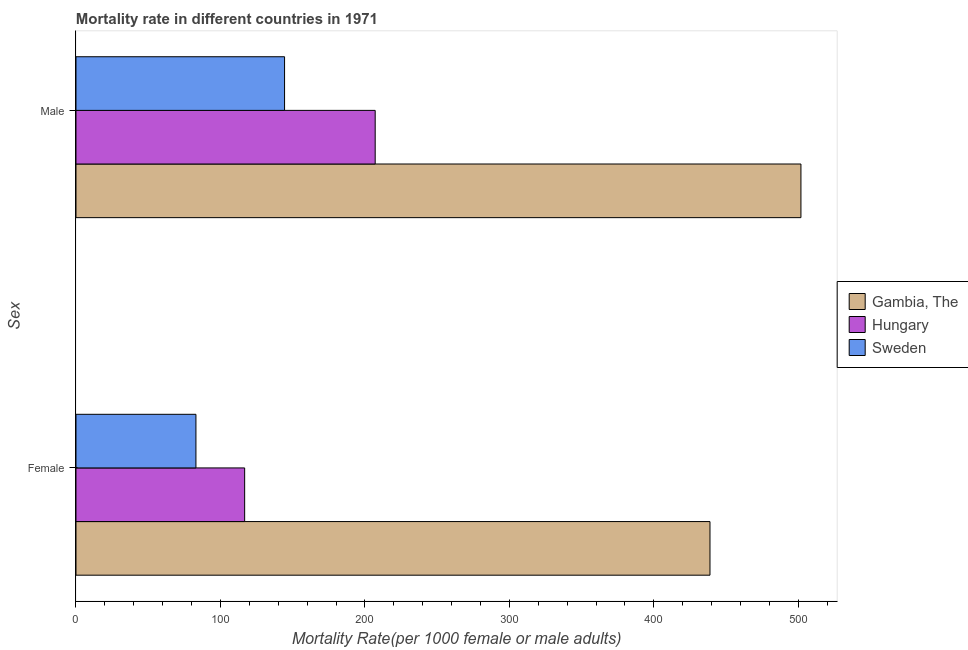How many different coloured bars are there?
Offer a very short reply. 3. How many bars are there on the 1st tick from the bottom?
Make the answer very short. 3. What is the male mortality rate in Sweden?
Offer a terse response. 144.39. Across all countries, what is the maximum female mortality rate?
Your answer should be very brief. 438.89. Across all countries, what is the minimum female mortality rate?
Provide a succinct answer. 83.04. In which country was the female mortality rate maximum?
Make the answer very short. Gambia, The. What is the total male mortality rate in the graph?
Offer a terse response. 853.37. What is the difference between the male mortality rate in Hungary and that in Sweden?
Keep it short and to the point. 62.74. What is the difference between the female mortality rate in Sweden and the male mortality rate in Gambia, The?
Your answer should be compact. -418.81. What is the average female mortality rate per country?
Keep it short and to the point. 212.9. What is the difference between the female mortality rate and male mortality rate in Sweden?
Provide a short and direct response. -61.35. In how many countries, is the female mortality rate greater than 40 ?
Ensure brevity in your answer.  3. What is the ratio of the male mortality rate in Hungary to that in Sweden?
Provide a short and direct response. 1.43. Is the female mortality rate in Hungary less than that in Gambia, The?
Your answer should be compact. Yes. What does the 1st bar from the top in Female represents?
Your answer should be compact. Sweden. What does the 1st bar from the bottom in Female represents?
Your answer should be very brief. Gambia, The. Are all the bars in the graph horizontal?
Your response must be concise. Yes. How many countries are there in the graph?
Give a very brief answer. 3. What is the difference between two consecutive major ticks on the X-axis?
Give a very brief answer. 100. Does the graph contain grids?
Provide a succinct answer. No. Where does the legend appear in the graph?
Keep it short and to the point. Center right. How many legend labels are there?
Your response must be concise. 3. How are the legend labels stacked?
Provide a short and direct response. Vertical. What is the title of the graph?
Offer a terse response. Mortality rate in different countries in 1971. Does "Australia" appear as one of the legend labels in the graph?
Offer a very short reply. No. What is the label or title of the X-axis?
Keep it short and to the point. Mortality Rate(per 1000 female or male adults). What is the label or title of the Y-axis?
Your response must be concise. Sex. What is the Mortality Rate(per 1000 female or male adults) of Gambia, The in Female?
Provide a succinct answer. 438.89. What is the Mortality Rate(per 1000 female or male adults) in Hungary in Female?
Your answer should be very brief. 116.76. What is the Mortality Rate(per 1000 female or male adults) of Sweden in Female?
Provide a succinct answer. 83.04. What is the Mortality Rate(per 1000 female or male adults) in Gambia, The in Male?
Make the answer very short. 501.85. What is the Mortality Rate(per 1000 female or male adults) of Hungary in Male?
Provide a short and direct response. 207.13. What is the Mortality Rate(per 1000 female or male adults) in Sweden in Male?
Offer a terse response. 144.39. Across all Sex, what is the maximum Mortality Rate(per 1000 female or male adults) in Gambia, The?
Your answer should be compact. 501.85. Across all Sex, what is the maximum Mortality Rate(per 1000 female or male adults) in Hungary?
Offer a terse response. 207.13. Across all Sex, what is the maximum Mortality Rate(per 1000 female or male adults) of Sweden?
Offer a terse response. 144.39. Across all Sex, what is the minimum Mortality Rate(per 1000 female or male adults) in Gambia, The?
Provide a short and direct response. 438.89. Across all Sex, what is the minimum Mortality Rate(per 1000 female or male adults) of Hungary?
Provide a succinct answer. 116.76. Across all Sex, what is the minimum Mortality Rate(per 1000 female or male adults) in Sweden?
Ensure brevity in your answer.  83.04. What is the total Mortality Rate(per 1000 female or male adults) in Gambia, The in the graph?
Make the answer very short. 940.75. What is the total Mortality Rate(per 1000 female or male adults) of Hungary in the graph?
Your answer should be very brief. 323.89. What is the total Mortality Rate(per 1000 female or male adults) of Sweden in the graph?
Give a very brief answer. 227.43. What is the difference between the Mortality Rate(per 1000 female or male adults) of Gambia, The in Female and that in Male?
Offer a very short reply. -62.96. What is the difference between the Mortality Rate(per 1000 female or male adults) in Hungary in Female and that in Male?
Give a very brief answer. -90.37. What is the difference between the Mortality Rate(per 1000 female or male adults) of Sweden in Female and that in Male?
Your answer should be very brief. -61.35. What is the difference between the Mortality Rate(per 1000 female or male adults) in Gambia, The in Female and the Mortality Rate(per 1000 female or male adults) in Hungary in Male?
Offer a very short reply. 231.77. What is the difference between the Mortality Rate(per 1000 female or male adults) in Gambia, The in Female and the Mortality Rate(per 1000 female or male adults) in Sweden in Male?
Your answer should be very brief. 294.51. What is the difference between the Mortality Rate(per 1000 female or male adults) of Hungary in Female and the Mortality Rate(per 1000 female or male adults) of Sweden in Male?
Keep it short and to the point. -27.63. What is the average Mortality Rate(per 1000 female or male adults) in Gambia, The per Sex?
Offer a very short reply. 470.37. What is the average Mortality Rate(per 1000 female or male adults) of Hungary per Sex?
Offer a terse response. 161.94. What is the average Mortality Rate(per 1000 female or male adults) of Sweden per Sex?
Offer a terse response. 113.71. What is the difference between the Mortality Rate(per 1000 female or male adults) of Gambia, The and Mortality Rate(per 1000 female or male adults) of Hungary in Female?
Offer a terse response. 322.13. What is the difference between the Mortality Rate(per 1000 female or male adults) in Gambia, The and Mortality Rate(per 1000 female or male adults) in Sweden in Female?
Keep it short and to the point. 355.85. What is the difference between the Mortality Rate(per 1000 female or male adults) of Hungary and Mortality Rate(per 1000 female or male adults) of Sweden in Female?
Provide a short and direct response. 33.72. What is the difference between the Mortality Rate(per 1000 female or male adults) of Gambia, The and Mortality Rate(per 1000 female or male adults) of Hungary in Male?
Your answer should be very brief. 294.72. What is the difference between the Mortality Rate(per 1000 female or male adults) in Gambia, The and Mortality Rate(per 1000 female or male adults) in Sweden in Male?
Provide a succinct answer. 357.46. What is the difference between the Mortality Rate(per 1000 female or male adults) in Hungary and Mortality Rate(per 1000 female or male adults) in Sweden in Male?
Ensure brevity in your answer.  62.74. What is the ratio of the Mortality Rate(per 1000 female or male adults) of Gambia, The in Female to that in Male?
Your response must be concise. 0.87. What is the ratio of the Mortality Rate(per 1000 female or male adults) of Hungary in Female to that in Male?
Provide a succinct answer. 0.56. What is the ratio of the Mortality Rate(per 1000 female or male adults) of Sweden in Female to that in Male?
Your answer should be very brief. 0.58. What is the difference between the highest and the second highest Mortality Rate(per 1000 female or male adults) of Gambia, The?
Ensure brevity in your answer.  62.96. What is the difference between the highest and the second highest Mortality Rate(per 1000 female or male adults) of Hungary?
Ensure brevity in your answer.  90.37. What is the difference between the highest and the second highest Mortality Rate(per 1000 female or male adults) in Sweden?
Your answer should be very brief. 61.35. What is the difference between the highest and the lowest Mortality Rate(per 1000 female or male adults) in Gambia, The?
Make the answer very short. 62.96. What is the difference between the highest and the lowest Mortality Rate(per 1000 female or male adults) in Hungary?
Provide a succinct answer. 90.37. What is the difference between the highest and the lowest Mortality Rate(per 1000 female or male adults) of Sweden?
Ensure brevity in your answer.  61.35. 